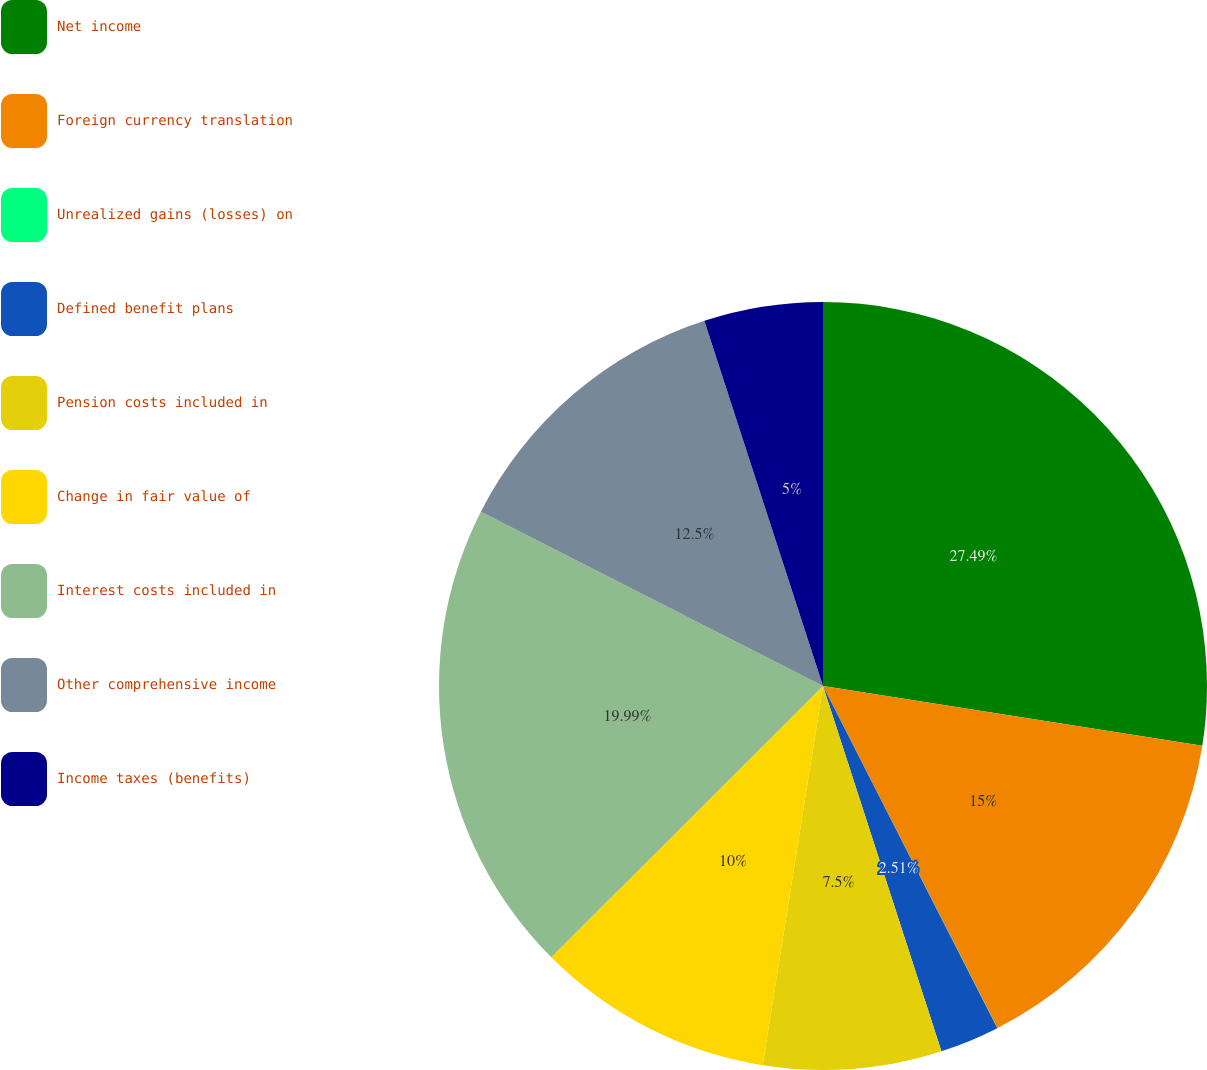Convert chart to OTSL. <chart><loc_0><loc_0><loc_500><loc_500><pie_chart><fcel>Net income<fcel>Foreign currency translation<fcel>Unrealized gains (losses) on<fcel>Defined benefit plans<fcel>Pension costs included in<fcel>Change in fair value of<fcel>Interest costs included in<fcel>Other comprehensive income<fcel>Income taxes (benefits)<nl><fcel>27.49%<fcel>15.0%<fcel>0.01%<fcel>2.51%<fcel>7.5%<fcel>10.0%<fcel>19.99%<fcel>12.5%<fcel>5.0%<nl></chart> 